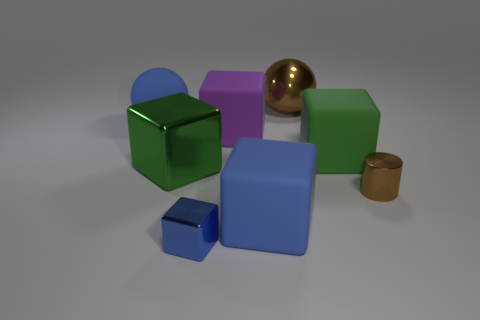Subtract all green cubes. How many cubes are left? 3 Subtract all blue balls. How many balls are left? 1 Subtract 0 red cubes. How many objects are left? 8 Subtract all spheres. How many objects are left? 6 Subtract 2 spheres. How many spheres are left? 0 Subtract all cyan cylinders. Subtract all brown balls. How many cylinders are left? 1 Subtract all red spheres. How many purple cubes are left? 1 Subtract all tiny shiny blocks. Subtract all large blue matte objects. How many objects are left? 5 Add 2 blue metal objects. How many blue metal objects are left? 3 Add 5 blue shiny things. How many blue shiny things exist? 6 